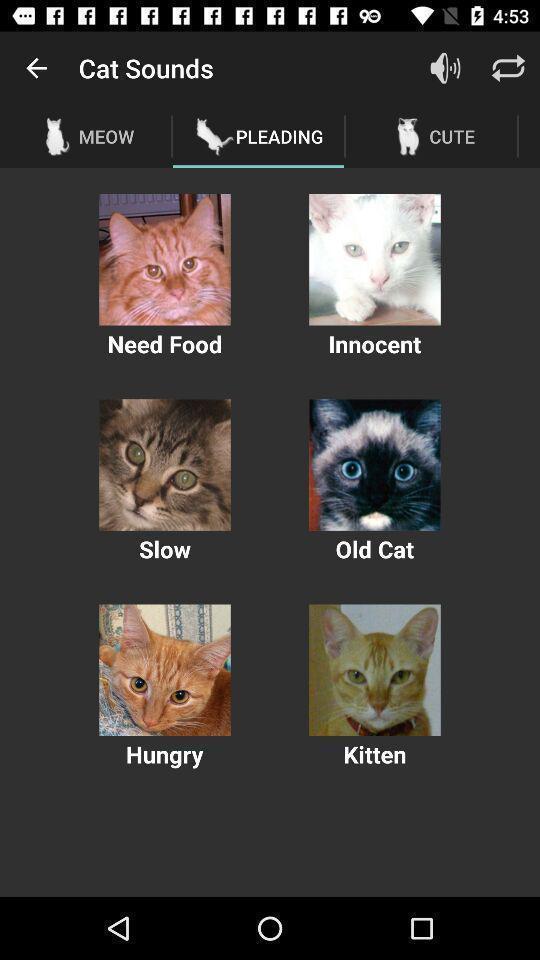Explain the elements present in this screenshot. Page with different cat sounds. 